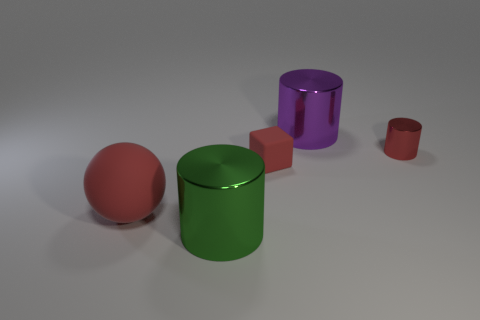Add 3 small gray rubber cubes. How many objects exist? 8 Subtract all spheres. How many objects are left? 4 Add 5 rubber cubes. How many rubber cubes are left? 6 Add 4 large metallic things. How many large metallic things exist? 6 Subtract 0 blue balls. How many objects are left? 5 Subtract all large red rubber cylinders. Subtract all red rubber blocks. How many objects are left? 4 